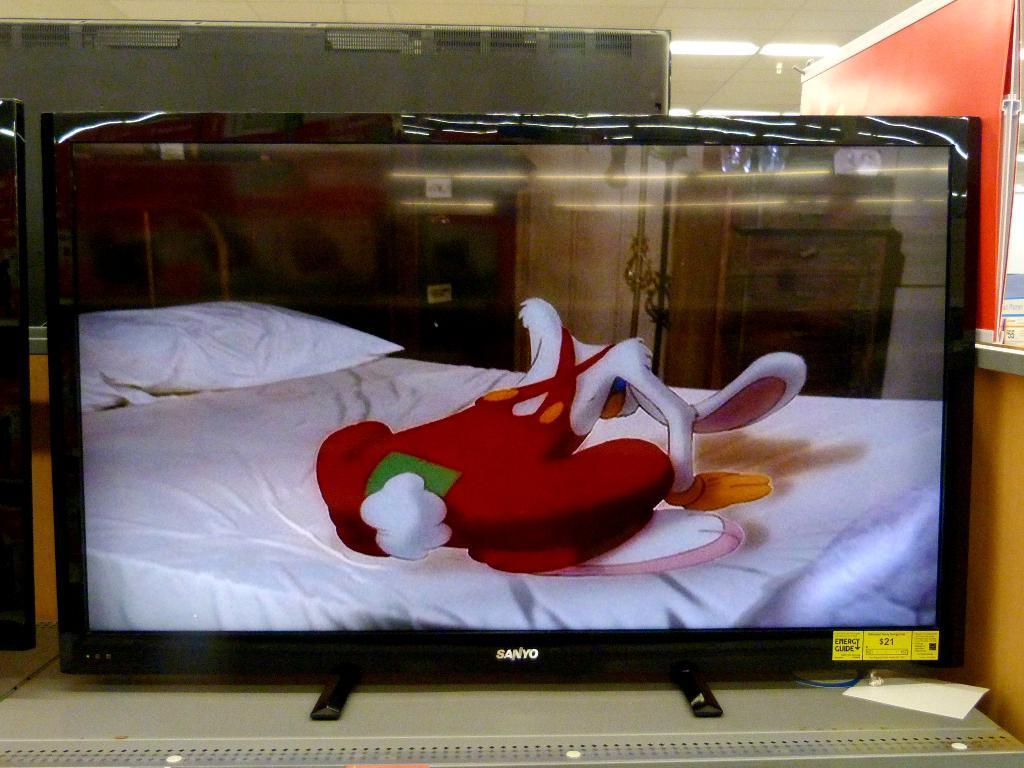Please provide a concise description of this image. There is a monitor. In which, there is a cartoon image. In the background, there are lights attached to the roof and there are other objects. 